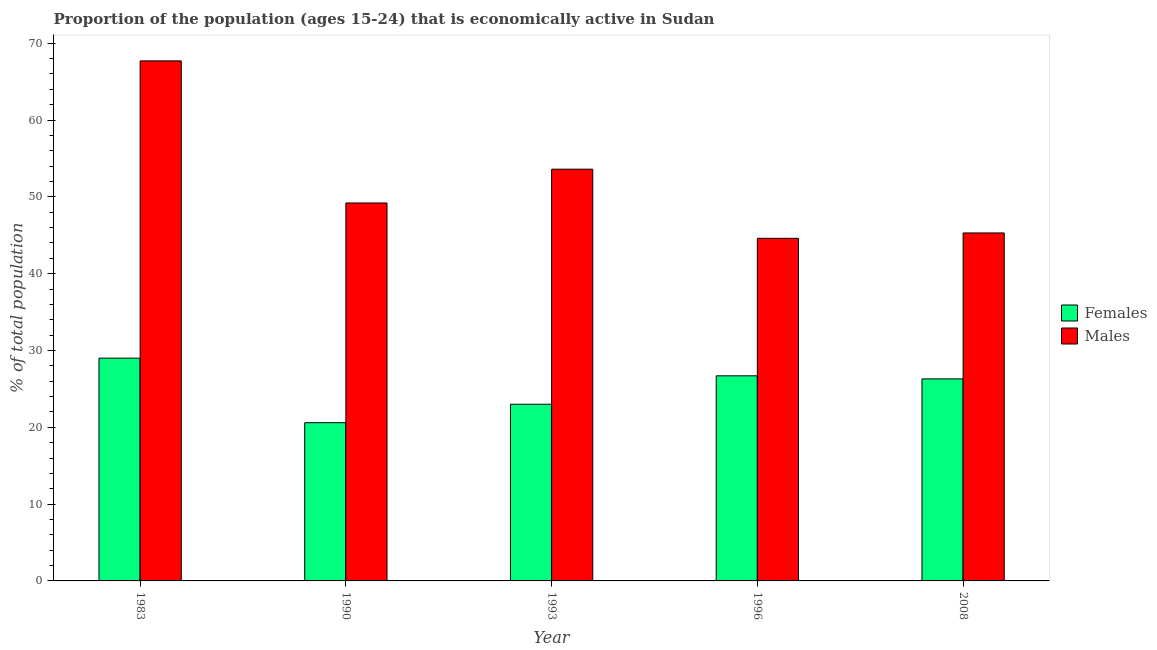How many different coloured bars are there?
Offer a very short reply. 2. Are the number of bars per tick equal to the number of legend labels?
Your response must be concise. Yes. How many bars are there on the 1st tick from the right?
Offer a terse response. 2. In how many cases, is the number of bars for a given year not equal to the number of legend labels?
Provide a succinct answer. 0. What is the percentage of economically active female population in 1990?
Keep it short and to the point. 20.6. Across all years, what is the maximum percentage of economically active male population?
Your response must be concise. 67.7. Across all years, what is the minimum percentage of economically active male population?
Make the answer very short. 44.6. In which year was the percentage of economically active male population maximum?
Offer a very short reply. 1983. What is the total percentage of economically active male population in the graph?
Offer a very short reply. 260.4. What is the difference between the percentage of economically active male population in 1990 and that in 1996?
Make the answer very short. 4.6. What is the difference between the percentage of economically active male population in 1983 and the percentage of economically active female population in 1993?
Give a very brief answer. 14.1. What is the average percentage of economically active female population per year?
Make the answer very short. 25.12. In how many years, is the percentage of economically active male population greater than 36 %?
Give a very brief answer. 5. What is the ratio of the percentage of economically active male population in 1993 to that in 1996?
Ensure brevity in your answer.  1.2. Is the percentage of economically active male population in 1983 less than that in 1990?
Your response must be concise. No. Is the difference between the percentage of economically active male population in 1983 and 1996 greater than the difference between the percentage of economically active female population in 1983 and 1996?
Provide a succinct answer. No. What is the difference between the highest and the second highest percentage of economically active male population?
Offer a terse response. 14.1. What is the difference between the highest and the lowest percentage of economically active female population?
Provide a succinct answer. 8.4. In how many years, is the percentage of economically active female population greater than the average percentage of economically active female population taken over all years?
Keep it short and to the point. 3. What does the 1st bar from the left in 1996 represents?
Keep it short and to the point. Females. What does the 1st bar from the right in 2008 represents?
Your answer should be compact. Males. How many bars are there?
Your answer should be compact. 10. How many years are there in the graph?
Keep it short and to the point. 5. What is the difference between two consecutive major ticks on the Y-axis?
Give a very brief answer. 10. Are the values on the major ticks of Y-axis written in scientific E-notation?
Keep it short and to the point. No. Does the graph contain any zero values?
Offer a terse response. No. How many legend labels are there?
Provide a succinct answer. 2. What is the title of the graph?
Your answer should be very brief. Proportion of the population (ages 15-24) that is economically active in Sudan. What is the label or title of the X-axis?
Your response must be concise. Year. What is the label or title of the Y-axis?
Provide a succinct answer. % of total population. What is the % of total population in Females in 1983?
Give a very brief answer. 29. What is the % of total population in Males in 1983?
Provide a short and direct response. 67.7. What is the % of total population in Females in 1990?
Provide a short and direct response. 20.6. What is the % of total population in Males in 1990?
Ensure brevity in your answer.  49.2. What is the % of total population of Males in 1993?
Provide a succinct answer. 53.6. What is the % of total population in Females in 1996?
Offer a very short reply. 26.7. What is the % of total population of Males in 1996?
Offer a very short reply. 44.6. What is the % of total population in Females in 2008?
Provide a succinct answer. 26.3. What is the % of total population in Males in 2008?
Provide a succinct answer. 45.3. Across all years, what is the maximum % of total population in Females?
Provide a succinct answer. 29. Across all years, what is the maximum % of total population of Males?
Offer a very short reply. 67.7. Across all years, what is the minimum % of total population in Females?
Ensure brevity in your answer.  20.6. Across all years, what is the minimum % of total population of Males?
Provide a short and direct response. 44.6. What is the total % of total population in Females in the graph?
Offer a terse response. 125.6. What is the total % of total population in Males in the graph?
Your answer should be very brief. 260.4. What is the difference between the % of total population of Females in 1983 and that in 1990?
Offer a terse response. 8.4. What is the difference between the % of total population in Males in 1983 and that in 1993?
Make the answer very short. 14.1. What is the difference between the % of total population of Males in 1983 and that in 1996?
Ensure brevity in your answer.  23.1. What is the difference between the % of total population in Males in 1983 and that in 2008?
Offer a terse response. 22.4. What is the difference between the % of total population of Females in 1990 and that in 1996?
Your answer should be very brief. -6.1. What is the difference between the % of total population of Males in 1990 and that in 1996?
Offer a terse response. 4.6. What is the difference between the % of total population of Females in 1993 and that in 1996?
Make the answer very short. -3.7. What is the difference between the % of total population in Females in 1993 and that in 2008?
Provide a succinct answer. -3.3. What is the difference between the % of total population in Females in 1996 and that in 2008?
Keep it short and to the point. 0.4. What is the difference between the % of total population of Males in 1996 and that in 2008?
Give a very brief answer. -0.7. What is the difference between the % of total population of Females in 1983 and the % of total population of Males in 1990?
Your answer should be compact. -20.2. What is the difference between the % of total population in Females in 1983 and the % of total population in Males in 1993?
Provide a succinct answer. -24.6. What is the difference between the % of total population in Females in 1983 and the % of total population in Males in 1996?
Make the answer very short. -15.6. What is the difference between the % of total population of Females in 1983 and the % of total population of Males in 2008?
Your response must be concise. -16.3. What is the difference between the % of total population in Females in 1990 and the % of total population in Males in 1993?
Provide a short and direct response. -33. What is the difference between the % of total population of Females in 1990 and the % of total population of Males in 2008?
Ensure brevity in your answer.  -24.7. What is the difference between the % of total population of Females in 1993 and the % of total population of Males in 1996?
Provide a short and direct response. -21.6. What is the difference between the % of total population in Females in 1993 and the % of total population in Males in 2008?
Your response must be concise. -22.3. What is the difference between the % of total population of Females in 1996 and the % of total population of Males in 2008?
Provide a succinct answer. -18.6. What is the average % of total population in Females per year?
Your answer should be very brief. 25.12. What is the average % of total population in Males per year?
Your response must be concise. 52.08. In the year 1983, what is the difference between the % of total population in Females and % of total population in Males?
Keep it short and to the point. -38.7. In the year 1990, what is the difference between the % of total population of Females and % of total population of Males?
Make the answer very short. -28.6. In the year 1993, what is the difference between the % of total population in Females and % of total population in Males?
Make the answer very short. -30.6. In the year 1996, what is the difference between the % of total population in Females and % of total population in Males?
Your answer should be very brief. -17.9. In the year 2008, what is the difference between the % of total population in Females and % of total population in Males?
Ensure brevity in your answer.  -19. What is the ratio of the % of total population in Females in 1983 to that in 1990?
Provide a short and direct response. 1.41. What is the ratio of the % of total population of Males in 1983 to that in 1990?
Keep it short and to the point. 1.38. What is the ratio of the % of total population of Females in 1983 to that in 1993?
Your answer should be very brief. 1.26. What is the ratio of the % of total population in Males in 1983 to that in 1993?
Offer a very short reply. 1.26. What is the ratio of the % of total population of Females in 1983 to that in 1996?
Ensure brevity in your answer.  1.09. What is the ratio of the % of total population of Males in 1983 to that in 1996?
Offer a terse response. 1.52. What is the ratio of the % of total population in Females in 1983 to that in 2008?
Keep it short and to the point. 1.1. What is the ratio of the % of total population of Males in 1983 to that in 2008?
Make the answer very short. 1.49. What is the ratio of the % of total population in Females in 1990 to that in 1993?
Keep it short and to the point. 0.9. What is the ratio of the % of total population in Males in 1990 to that in 1993?
Provide a short and direct response. 0.92. What is the ratio of the % of total population of Females in 1990 to that in 1996?
Make the answer very short. 0.77. What is the ratio of the % of total population in Males in 1990 to that in 1996?
Offer a very short reply. 1.1. What is the ratio of the % of total population in Females in 1990 to that in 2008?
Your answer should be very brief. 0.78. What is the ratio of the % of total population of Males in 1990 to that in 2008?
Provide a succinct answer. 1.09. What is the ratio of the % of total population of Females in 1993 to that in 1996?
Ensure brevity in your answer.  0.86. What is the ratio of the % of total population in Males in 1993 to that in 1996?
Your response must be concise. 1.2. What is the ratio of the % of total population in Females in 1993 to that in 2008?
Give a very brief answer. 0.87. What is the ratio of the % of total population in Males in 1993 to that in 2008?
Your response must be concise. 1.18. What is the ratio of the % of total population of Females in 1996 to that in 2008?
Provide a succinct answer. 1.02. What is the ratio of the % of total population in Males in 1996 to that in 2008?
Make the answer very short. 0.98. What is the difference between the highest and the second highest % of total population in Males?
Make the answer very short. 14.1. What is the difference between the highest and the lowest % of total population of Females?
Offer a very short reply. 8.4. What is the difference between the highest and the lowest % of total population in Males?
Make the answer very short. 23.1. 